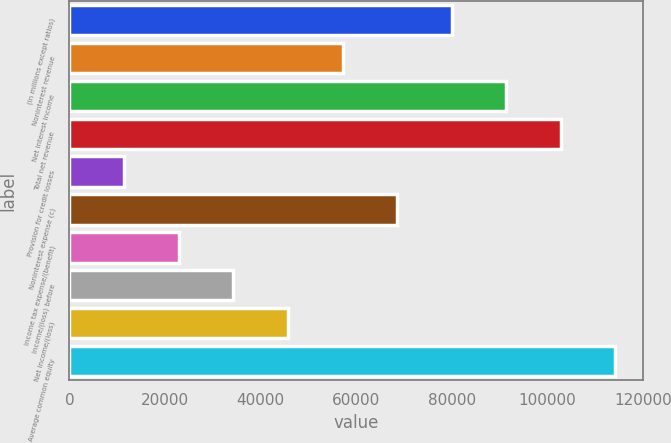Convert chart. <chart><loc_0><loc_0><loc_500><loc_500><bar_chart><fcel>(in millions except ratios)<fcel>Noninterest revenue<fcel>Net interest income<fcel>Total net revenue<fcel>Provision for credit losses<fcel>Noninterest expense (c)<fcel>Income tax expense/(benefit)<fcel>Income/(loss) before<fcel>Net income/(loss)<fcel>Average common equity<nl><fcel>80021.6<fcel>57170<fcel>91447.4<fcel>102873<fcel>11466.8<fcel>68595.8<fcel>22892.6<fcel>34318.4<fcel>45744.2<fcel>114299<nl></chart> 